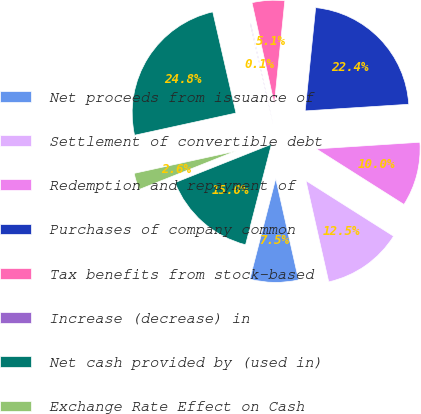Convert chart. <chart><loc_0><loc_0><loc_500><loc_500><pie_chart><fcel>Net proceeds from issuance of<fcel>Settlement of convertible debt<fcel>Redemption and repayment of<fcel>Purchases of company common<fcel>Tax benefits from stock-based<fcel>Increase (decrease) in<fcel>Net cash provided by (used in)<fcel>Exchange Rate Effect on Cash<fcel>Increase (Decrease) in Cash<nl><fcel>7.54%<fcel>12.48%<fcel>10.01%<fcel>22.37%<fcel>5.07%<fcel>0.13%<fcel>24.84%<fcel>2.6%<fcel>14.96%<nl></chart> 